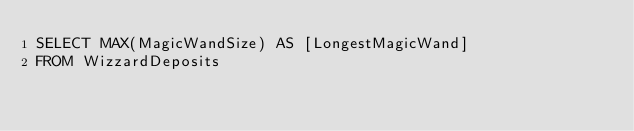<code> <loc_0><loc_0><loc_500><loc_500><_SQL_>SELECT MAX(MagicWandSize) AS [LongestMagicWand]
FROM WizzardDeposits
</code> 